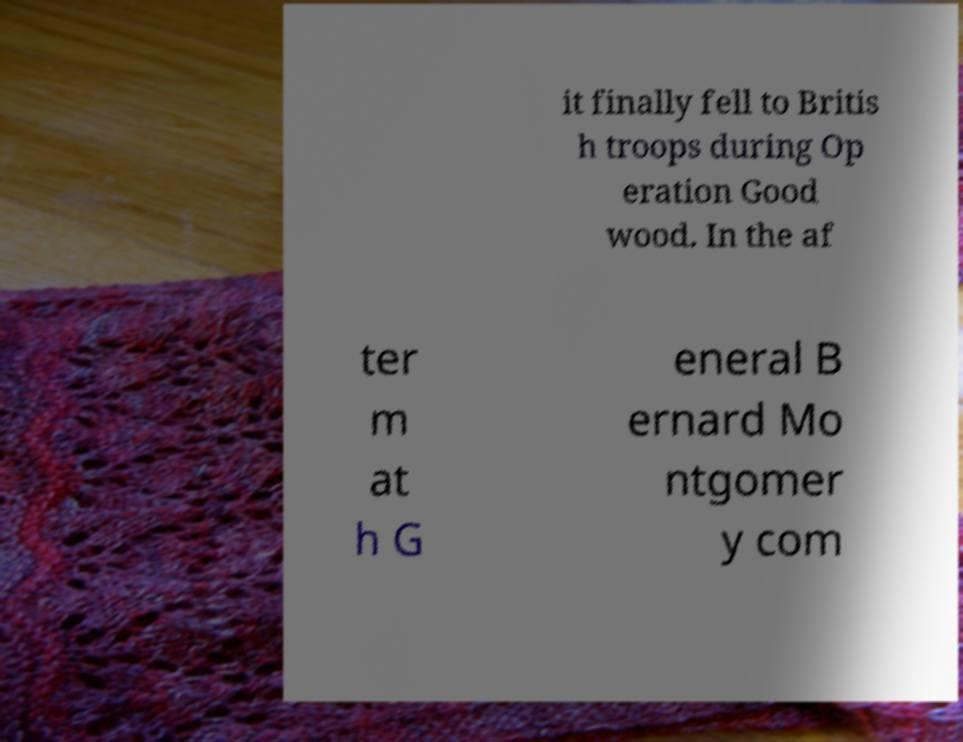Can you accurately transcribe the text from the provided image for me? it finally fell to Britis h troops during Op eration Good wood. In the af ter m at h G eneral B ernard Mo ntgomer y com 